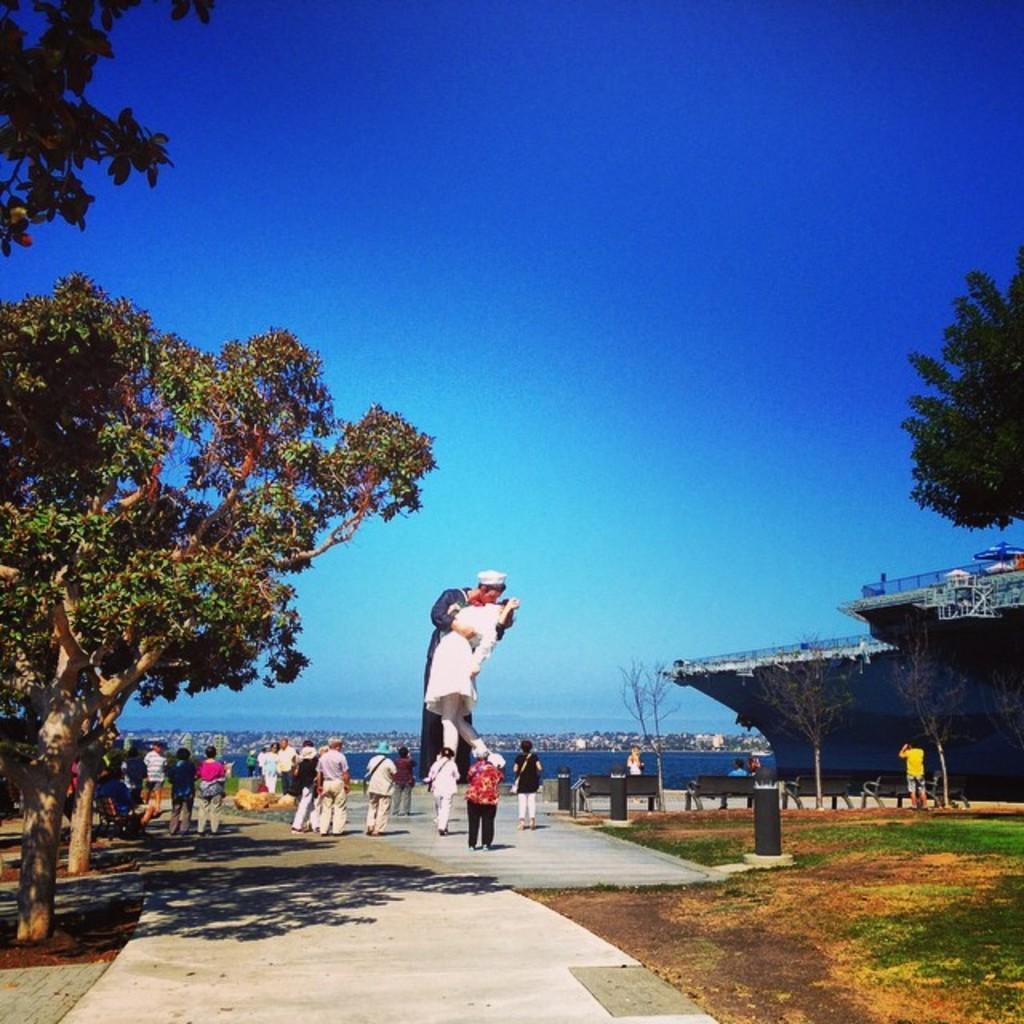How would you summarize this image in a sentence or two? In this picture I can see there is a man and woman statue here and there some people standing here and there is a tree, there is a ship here. In the backdrop there is a ocean and the sky is clear. 